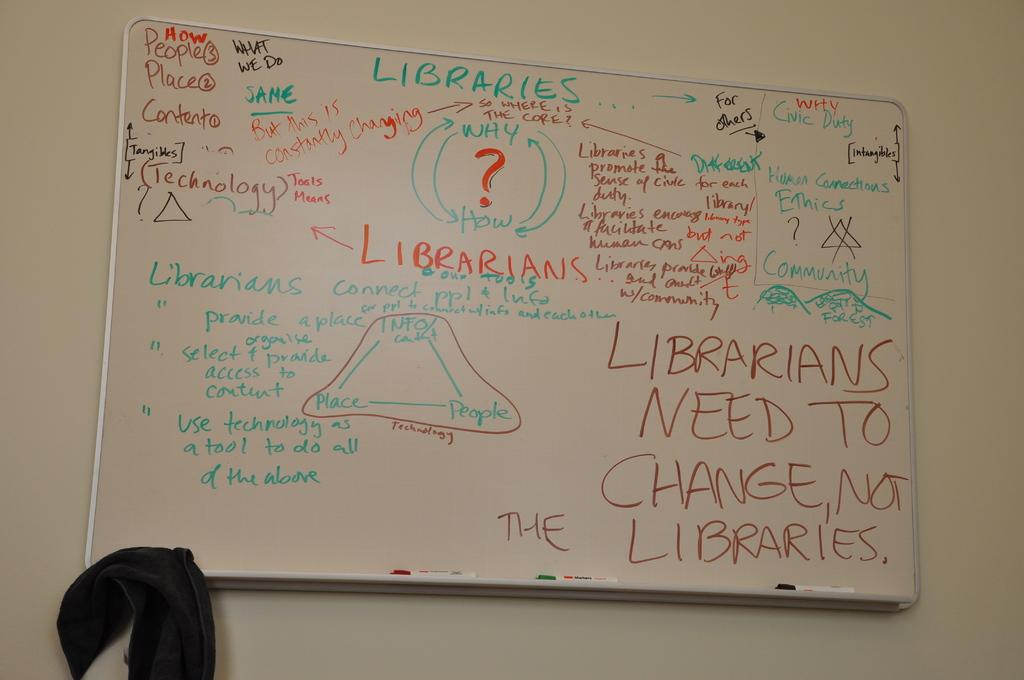<image>
Summarize the visual content of the image. A white board which reads 'Librarians need to change, not libraries'. 